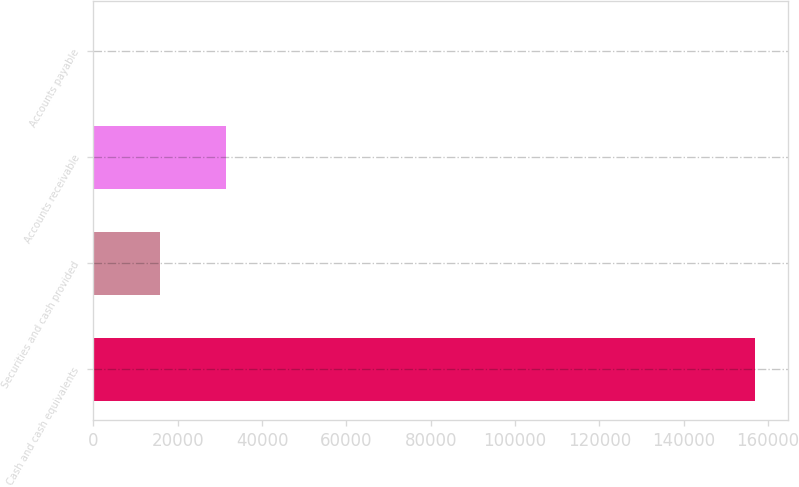Convert chart. <chart><loc_0><loc_0><loc_500><loc_500><bar_chart><fcel>Cash and cash equivalents<fcel>Securities and cash provided<fcel>Accounts receivable<fcel>Accounts payable<nl><fcel>156982<fcel>15775.6<fcel>31465.2<fcel>86<nl></chart> 